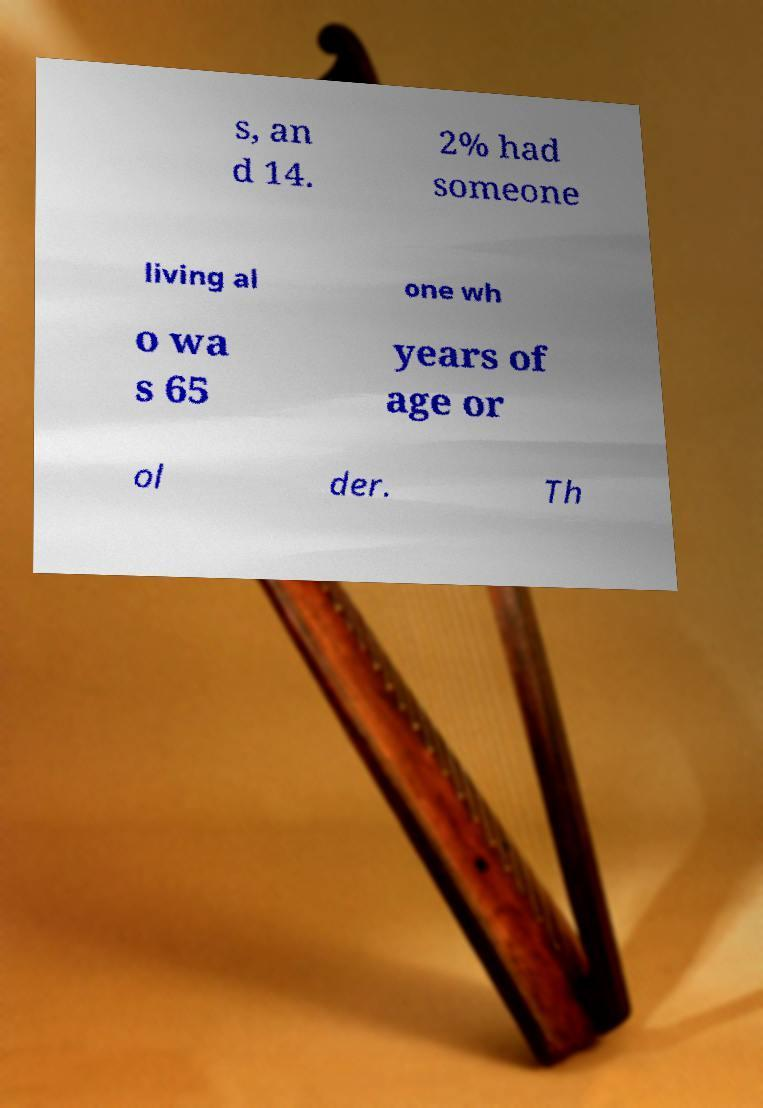There's text embedded in this image that I need extracted. Can you transcribe it verbatim? s, an d 14. 2% had someone living al one wh o wa s 65 years of age or ol der. Th 